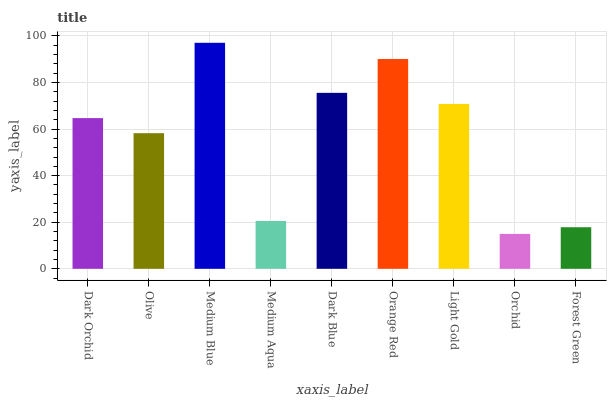Is Orchid the minimum?
Answer yes or no. Yes. Is Medium Blue the maximum?
Answer yes or no. Yes. Is Olive the minimum?
Answer yes or no. No. Is Olive the maximum?
Answer yes or no. No. Is Dark Orchid greater than Olive?
Answer yes or no. Yes. Is Olive less than Dark Orchid?
Answer yes or no. Yes. Is Olive greater than Dark Orchid?
Answer yes or no. No. Is Dark Orchid less than Olive?
Answer yes or no. No. Is Dark Orchid the high median?
Answer yes or no. Yes. Is Dark Orchid the low median?
Answer yes or no. Yes. Is Medium Aqua the high median?
Answer yes or no. No. Is Medium Aqua the low median?
Answer yes or no. No. 